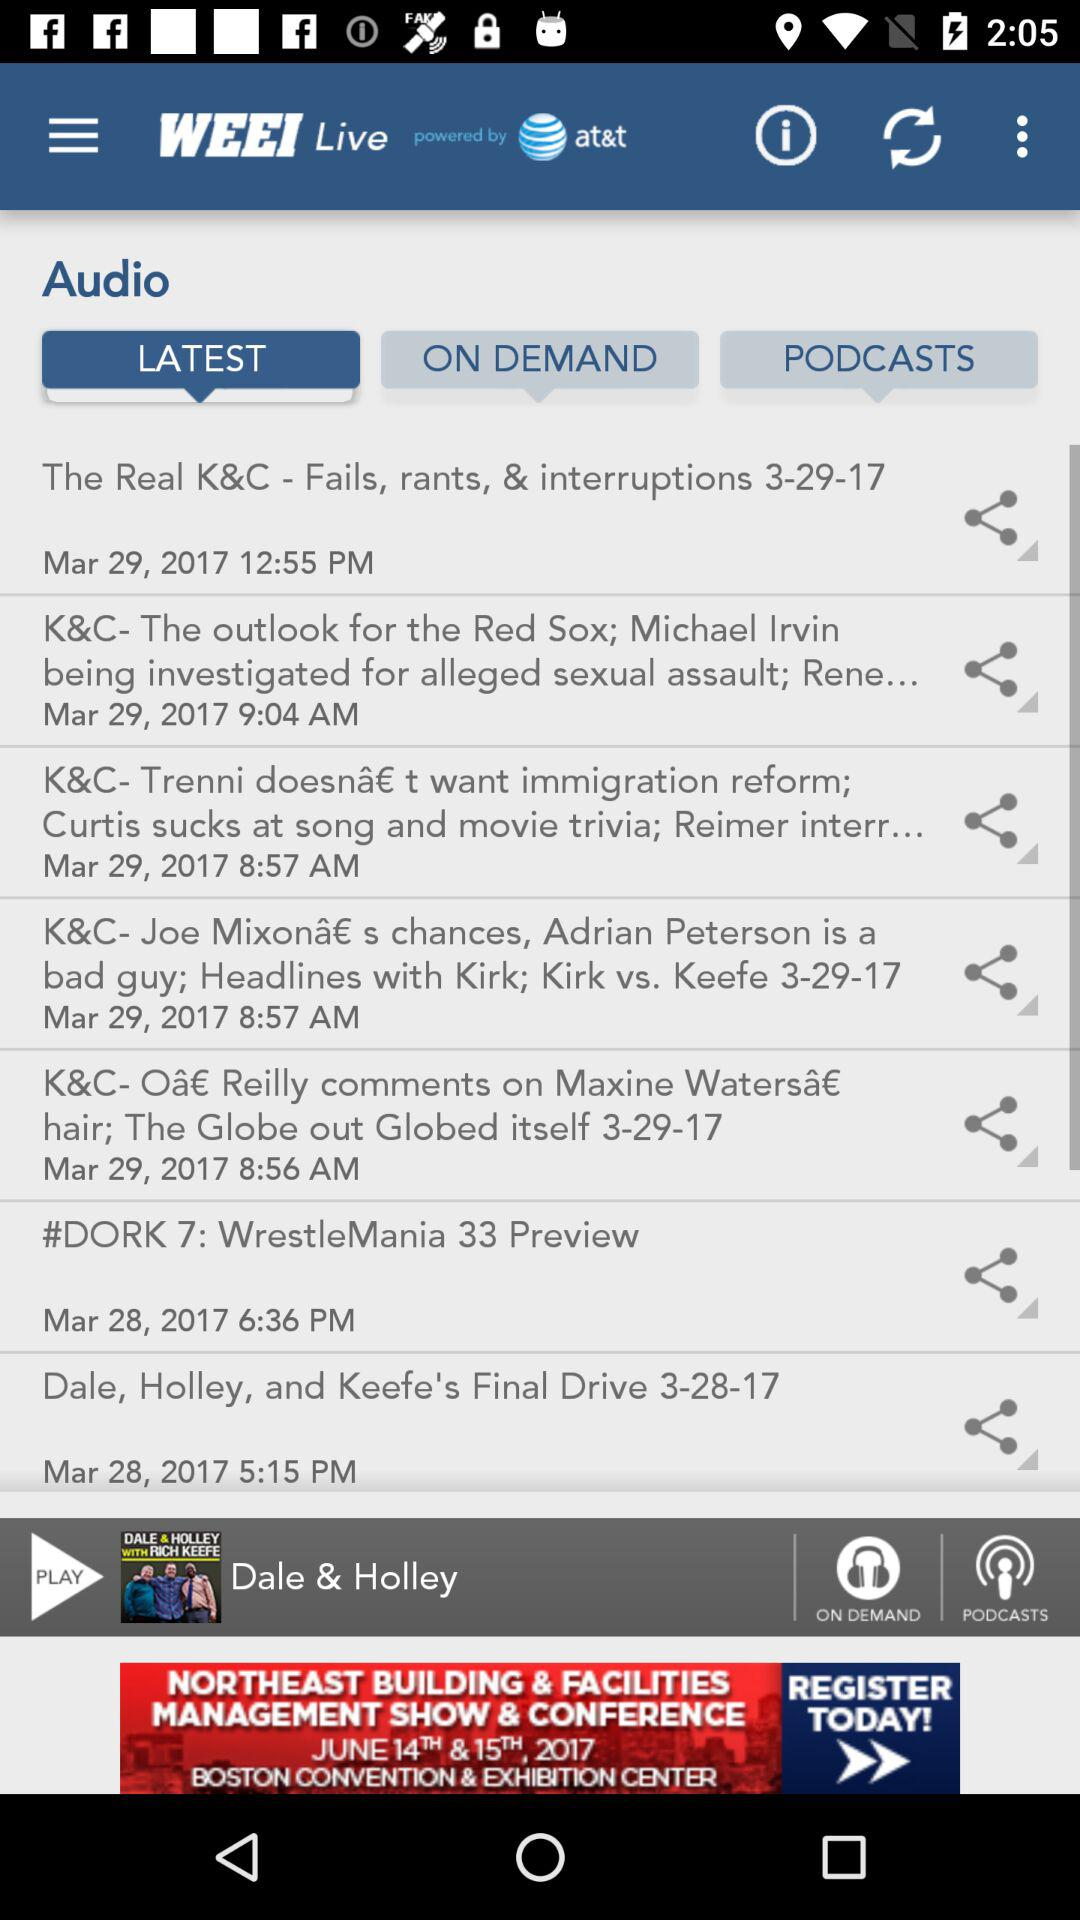What is the application name? The application name is "WEEI Live". 